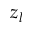Convert formula to latex. <formula><loc_0><loc_0><loc_500><loc_500>z _ { l }</formula> 